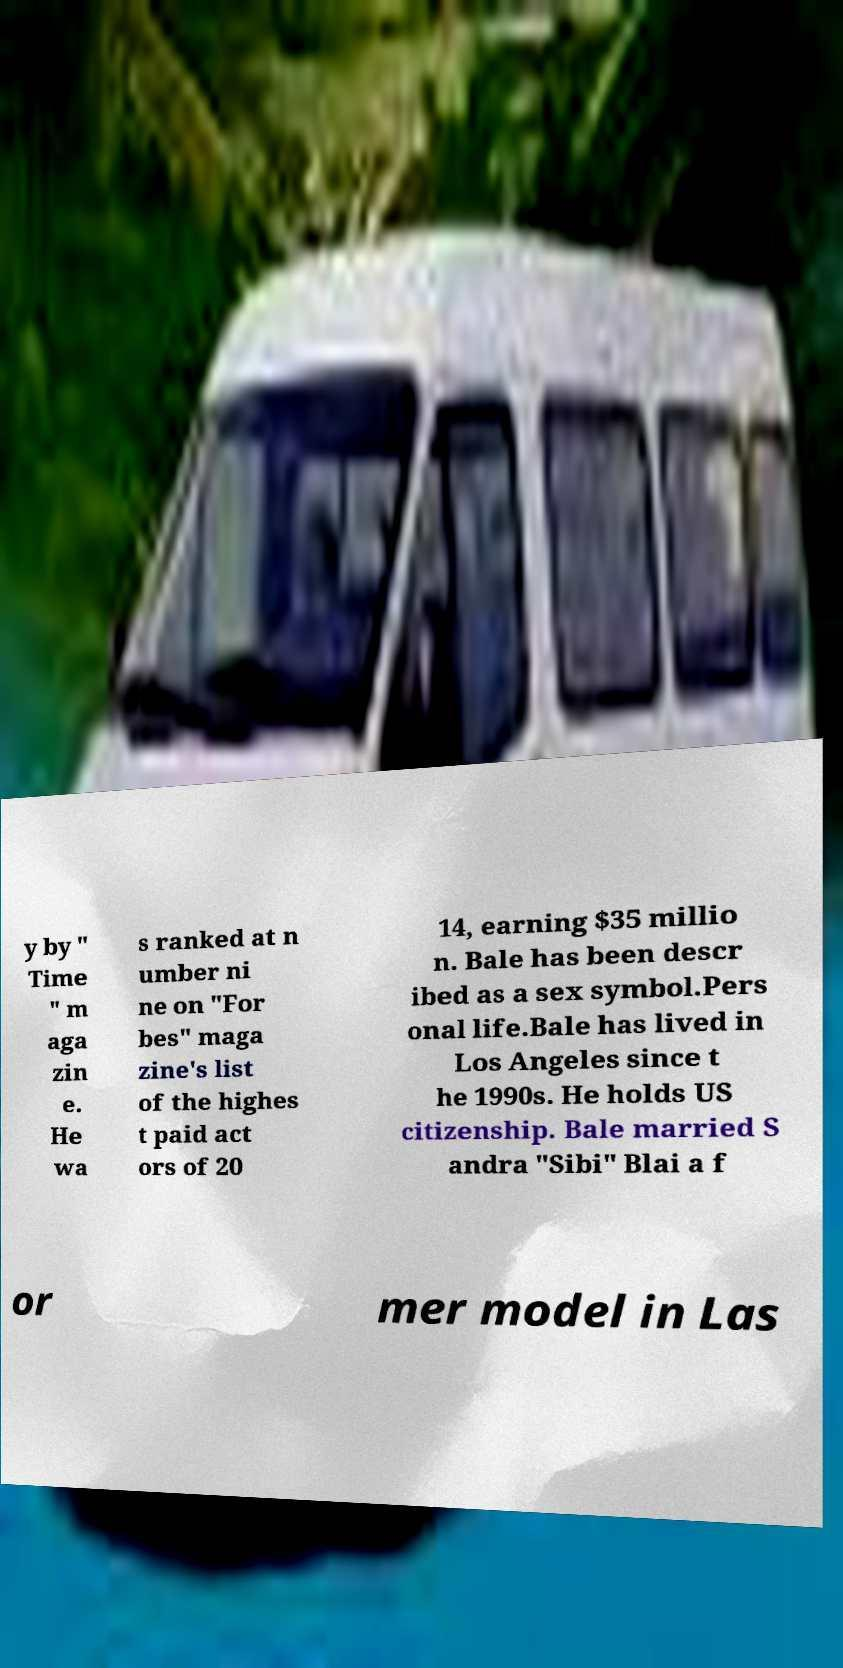Could you extract and type out the text from this image? y by " Time " m aga zin e. He wa s ranked at n umber ni ne on "For bes" maga zine's list of the highes t paid act ors of 20 14, earning $35 millio n. Bale has been descr ibed as a sex symbol.Pers onal life.Bale has lived in Los Angeles since t he 1990s. He holds US citizenship. Bale married S andra "Sibi" Blai a f or mer model in Las 